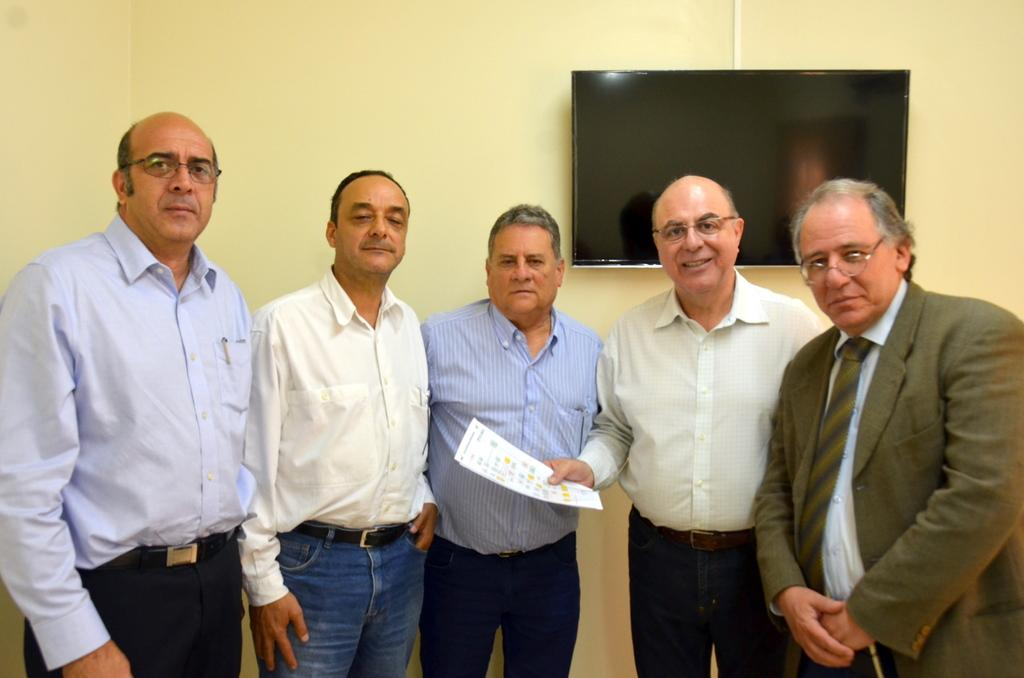How many men are present in the image? There are five men standing in the image. What is one of the men holding in his hand? One man is holding papers in his hand. What can be seen in the background of the image? There is a wall in the background of the image. What is on the wall in the background? There is a TV on the wall in the background. How many cats can be seen climbing on the TV in the image? There are no cats present in the image, and therefore no cats can be seen climbing on the TV. 